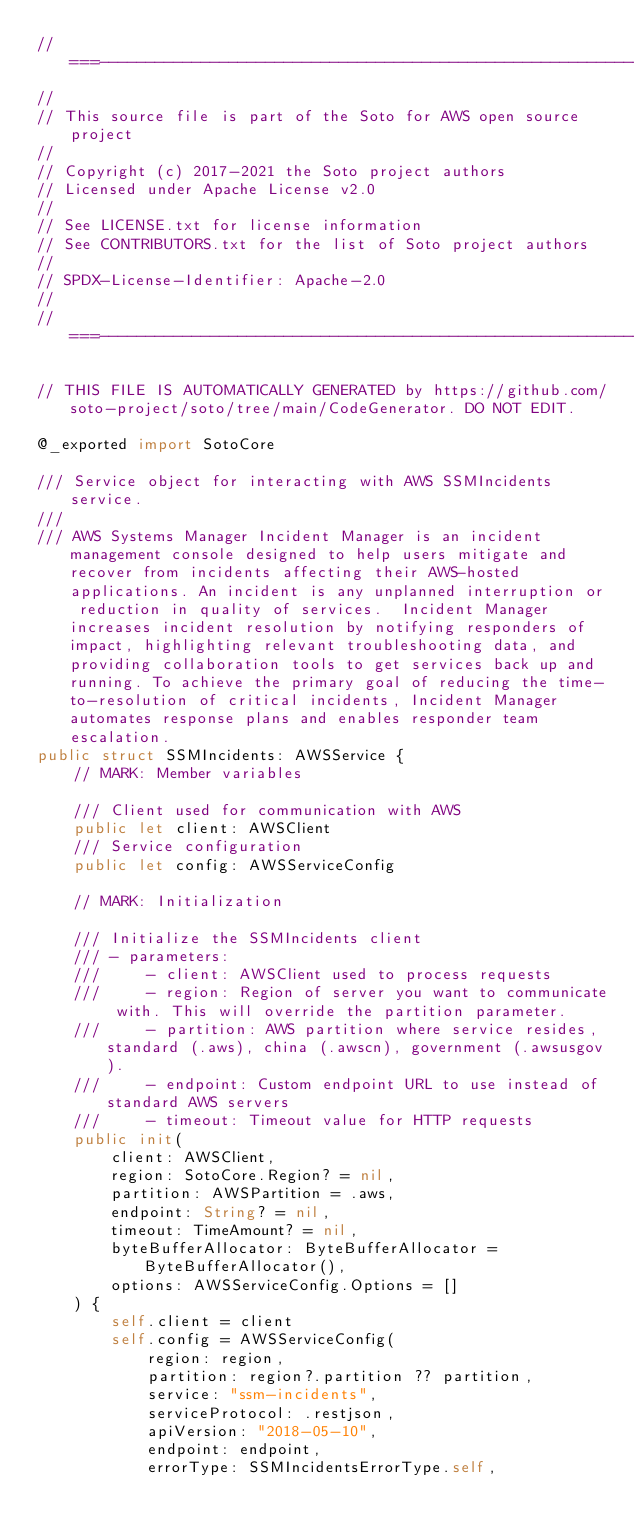Convert code to text. <code><loc_0><loc_0><loc_500><loc_500><_Swift_>//===----------------------------------------------------------------------===//
//
// This source file is part of the Soto for AWS open source project
//
// Copyright (c) 2017-2021 the Soto project authors
// Licensed under Apache License v2.0
//
// See LICENSE.txt for license information
// See CONTRIBUTORS.txt for the list of Soto project authors
//
// SPDX-License-Identifier: Apache-2.0
//
//===----------------------------------------------------------------------===//

// THIS FILE IS AUTOMATICALLY GENERATED by https://github.com/soto-project/soto/tree/main/CodeGenerator. DO NOT EDIT.

@_exported import SotoCore

/// Service object for interacting with AWS SSMIncidents service.
///
/// AWS Systems Manager Incident Manager is an incident management console designed to help users mitigate and recover from incidents affecting their AWS-hosted applications. An incident is any unplanned interruption or reduction in quality of services.  Incident Manager increases incident resolution by notifying responders of impact, highlighting relevant troubleshooting data, and providing collaboration tools to get services back up and running. To achieve the primary goal of reducing the time-to-resolution of critical incidents, Incident Manager automates response plans and enables responder team escalation.
public struct SSMIncidents: AWSService {
    // MARK: Member variables

    /// Client used for communication with AWS
    public let client: AWSClient
    /// Service configuration
    public let config: AWSServiceConfig

    // MARK: Initialization

    /// Initialize the SSMIncidents client
    /// - parameters:
    ///     - client: AWSClient used to process requests
    ///     - region: Region of server you want to communicate with. This will override the partition parameter.
    ///     - partition: AWS partition where service resides, standard (.aws), china (.awscn), government (.awsusgov).
    ///     - endpoint: Custom endpoint URL to use instead of standard AWS servers
    ///     - timeout: Timeout value for HTTP requests
    public init(
        client: AWSClient,
        region: SotoCore.Region? = nil,
        partition: AWSPartition = .aws,
        endpoint: String? = nil,
        timeout: TimeAmount? = nil,
        byteBufferAllocator: ByteBufferAllocator = ByteBufferAllocator(),
        options: AWSServiceConfig.Options = []
    ) {
        self.client = client
        self.config = AWSServiceConfig(
            region: region,
            partition: region?.partition ?? partition,
            service: "ssm-incidents",
            serviceProtocol: .restjson,
            apiVersion: "2018-05-10",
            endpoint: endpoint,
            errorType: SSMIncidentsErrorType.self,</code> 